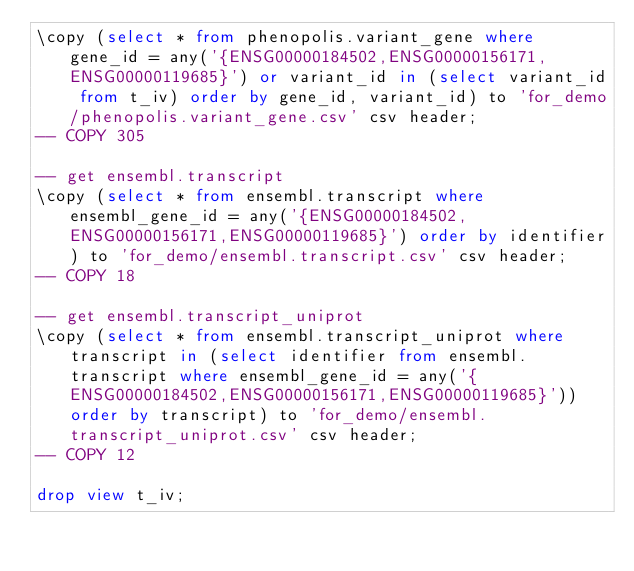Convert code to text. <code><loc_0><loc_0><loc_500><loc_500><_SQL_>\copy (select * from phenopolis.variant_gene where gene_id = any('{ENSG00000184502,ENSG00000156171,ENSG00000119685}') or variant_id in (select variant_id from t_iv) order by gene_id, variant_id) to 'for_demo/phenopolis.variant_gene.csv' csv header;
-- COPY 305

-- get ensembl.transcript
\copy (select * from ensembl.transcript where ensembl_gene_id = any('{ENSG00000184502,ENSG00000156171,ENSG00000119685}') order by identifier) to 'for_demo/ensembl.transcript.csv' csv header;
-- COPY 18

-- get ensembl.transcript_uniprot
\copy (select * from ensembl.transcript_uniprot where transcript in (select identifier from ensembl.transcript where ensembl_gene_id = any('{ENSG00000184502,ENSG00000156171,ENSG00000119685}')) order by transcript) to 'for_demo/ensembl.transcript_uniprot.csv' csv header;
-- COPY 12

drop view t_iv;</code> 